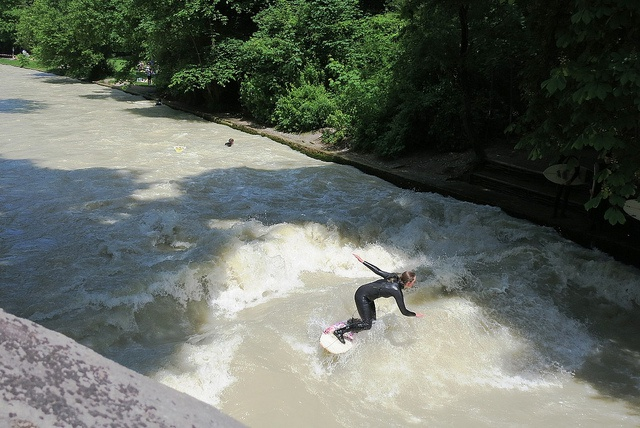Describe the objects in this image and their specific colors. I can see people in black, gray, and darkgray tones, surfboard in black, white, darkgray, and pink tones, surfboard in black tones, people in black tones, and surfboard in black tones in this image. 